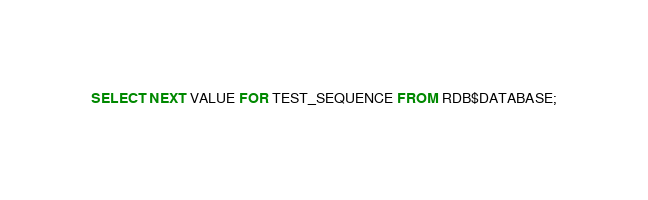Convert code to text. <code><loc_0><loc_0><loc_500><loc_500><_SQL_>SELECT NEXT VALUE FOR TEST_SEQUENCE FROM RDB$DATABASE;</code> 